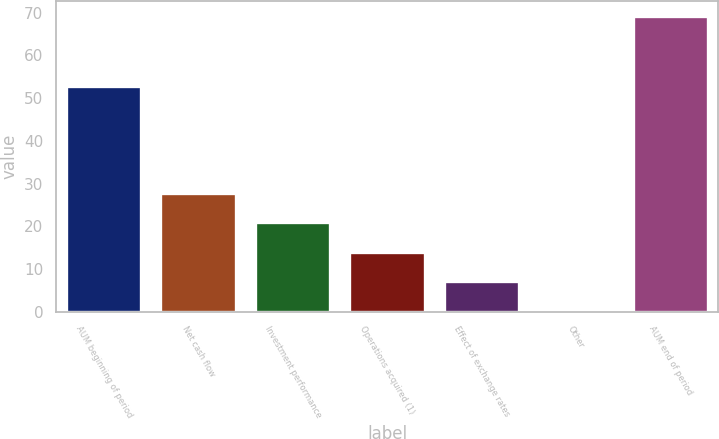Convert chart. <chart><loc_0><loc_0><loc_500><loc_500><bar_chart><fcel>AUM beginning of period<fcel>Net cash flow<fcel>Investment performance<fcel>Operations acquired (1)<fcel>Effect of exchange rates<fcel>Other<fcel>AUM end of period<nl><fcel>52.8<fcel>27.84<fcel>20.93<fcel>14.02<fcel>7.11<fcel>0.2<fcel>69.3<nl></chart> 